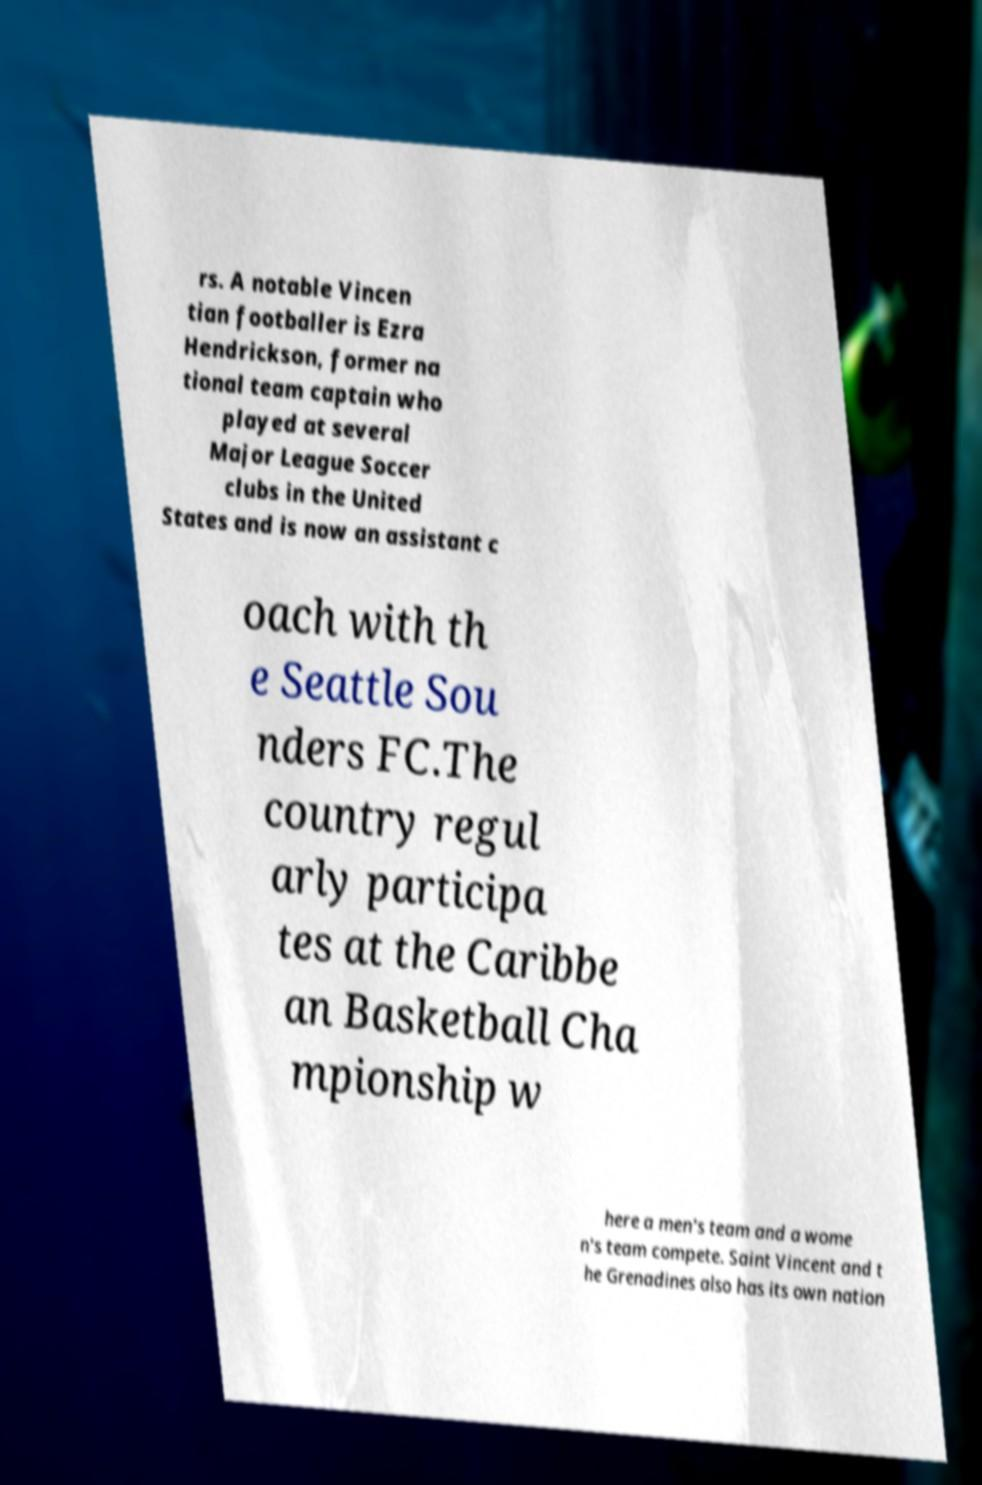Could you extract and type out the text from this image? rs. A notable Vincen tian footballer is Ezra Hendrickson, former na tional team captain who played at several Major League Soccer clubs in the United States and is now an assistant c oach with th e Seattle Sou nders FC.The country regul arly participa tes at the Caribbe an Basketball Cha mpionship w here a men's team and a wome n's team compete. Saint Vincent and t he Grenadines also has its own nation 